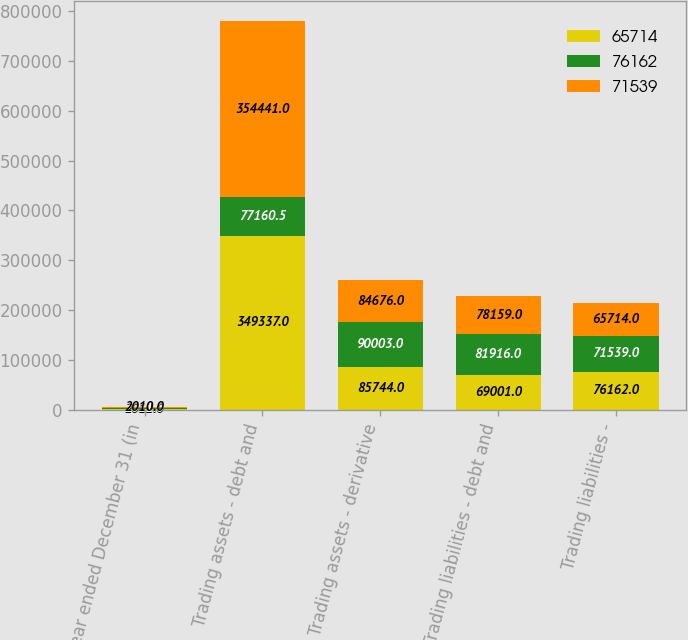<chart> <loc_0><loc_0><loc_500><loc_500><stacked_bar_chart><ecel><fcel>Year ended December 31 (in<fcel>Trading assets - debt and<fcel>Trading assets - derivative<fcel>Trading liabilities - debt and<fcel>Trading liabilities -<nl><fcel>65714<fcel>2012<fcel>349337<fcel>85744<fcel>69001<fcel>76162<nl><fcel>76162<fcel>2011<fcel>77160.5<fcel>90003<fcel>81916<fcel>71539<nl><fcel>71539<fcel>2010<fcel>354441<fcel>84676<fcel>78159<fcel>65714<nl></chart> 